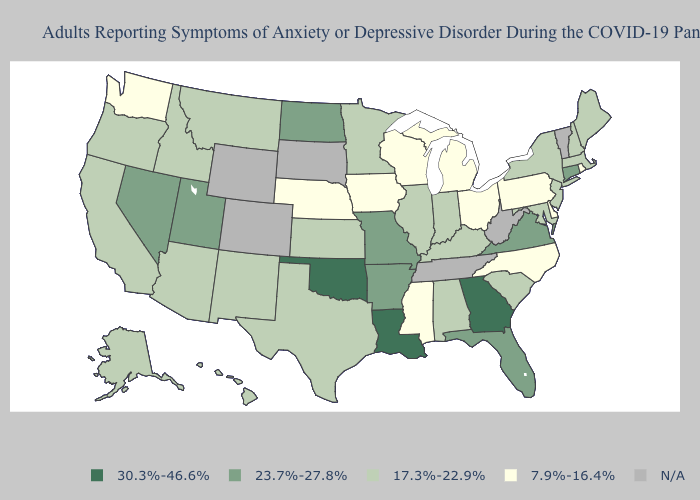Name the states that have a value in the range N/A?
Answer briefly. Colorado, South Dakota, Tennessee, Vermont, West Virginia, Wyoming. Name the states that have a value in the range 30.3%-46.6%?
Answer briefly. Georgia, Louisiana, Oklahoma. Name the states that have a value in the range 23.7%-27.8%?
Concise answer only. Arkansas, Connecticut, Florida, Missouri, Nevada, North Dakota, Utah, Virginia. Name the states that have a value in the range 17.3%-22.9%?
Give a very brief answer. Alabama, Alaska, Arizona, California, Hawaii, Idaho, Illinois, Indiana, Kansas, Kentucky, Maine, Maryland, Massachusetts, Minnesota, Montana, New Hampshire, New Jersey, New Mexico, New York, Oregon, South Carolina, Texas. Name the states that have a value in the range N/A?
Answer briefly. Colorado, South Dakota, Tennessee, Vermont, West Virginia, Wyoming. What is the highest value in the MidWest ?
Short answer required. 23.7%-27.8%. What is the value of Nebraska?
Short answer required. 7.9%-16.4%. What is the value of Maryland?
Quick response, please. 17.3%-22.9%. Name the states that have a value in the range 30.3%-46.6%?
Short answer required. Georgia, Louisiana, Oklahoma. Name the states that have a value in the range 17.3%-22.9%?
Short answer required. Alabama, Alaska, Arizona, California, Hawaii, Idaho, Illinois, Indiana, Kansas, Kentucky, Maine, Maryland, Massachusetts, Minnesota, Montana, New Hampshire, New Jersey, New Mexico, New York, Oregon, South Carolina, Texas. Is the legend a continuous bar?
Be succinct. No. Among the states that border Idaho , does Utah have the highest value?
Give a very brief answer. Yes. Does the first symbol in the legend represent the smallest category?
Give a very brief answer. No. Which states have the lowest value in the MidWest?
Quick response, please. Iowa, Michigan, Nebraska, Ohio, Wisconsin. 